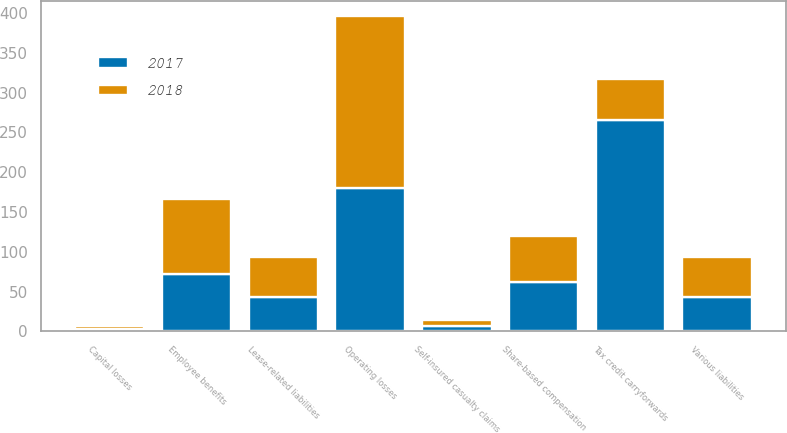Convert chart. <chart><loc_0><loc_0><loc_500><loc_500><stacked_bar_chart><ecel><fcel>Operating losses<fcel>Capital losses<fcel>Tax credit carryforwards<fcel>Employee benefits<fcel>Share-based compensation<fcel>Self-insured casualty claims<fcel>Lease-related liabilities<fcel>Various liabilities<nl><fcel>2017<fcel>180<fcel>3<fcel>266<fcel>72<fcel>62<fcel>7<fcel>43<fcel>43<nl><fcel>2018<fcel>216<fcel>4<fcel>51<fcel>94<fcel>58<fcel>7<fcel>51<fcel>51<nl></chart> 